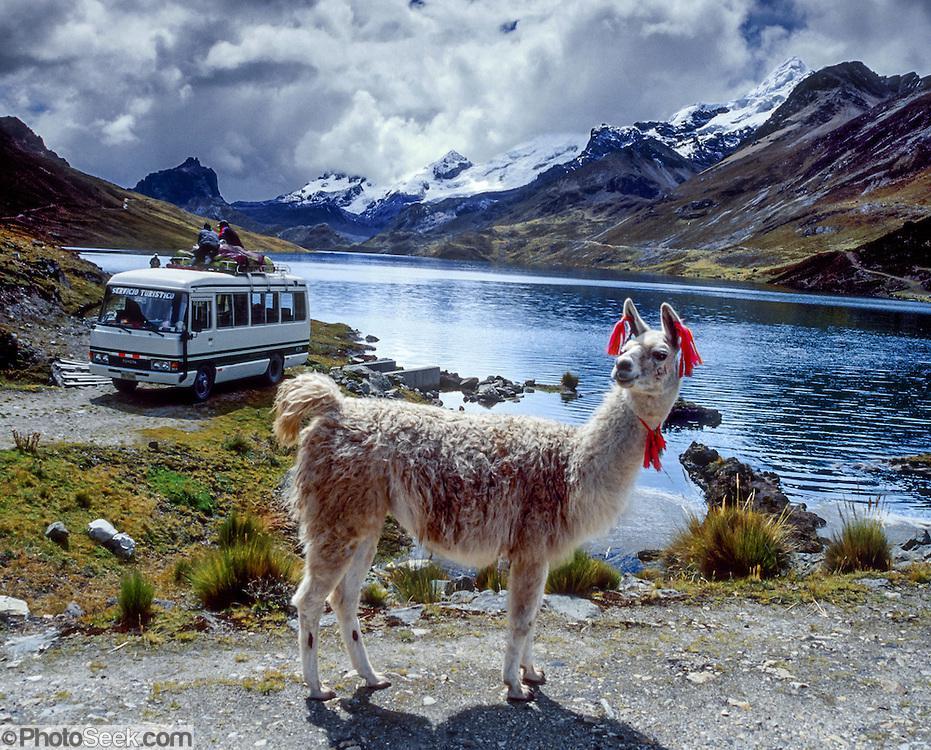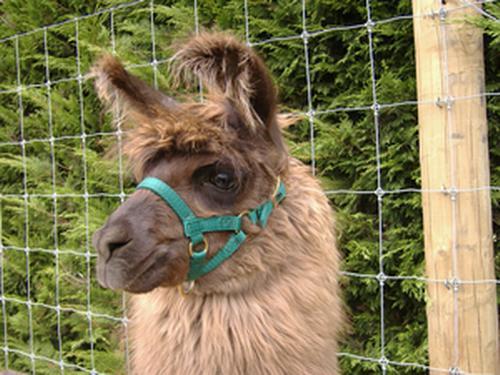The first image is the image on the left, the second image is the image on the right. For the images shown, is this caption "Red material hangs from the ears of the animal in the image on the left." true? Answer yes or no. Yes. 